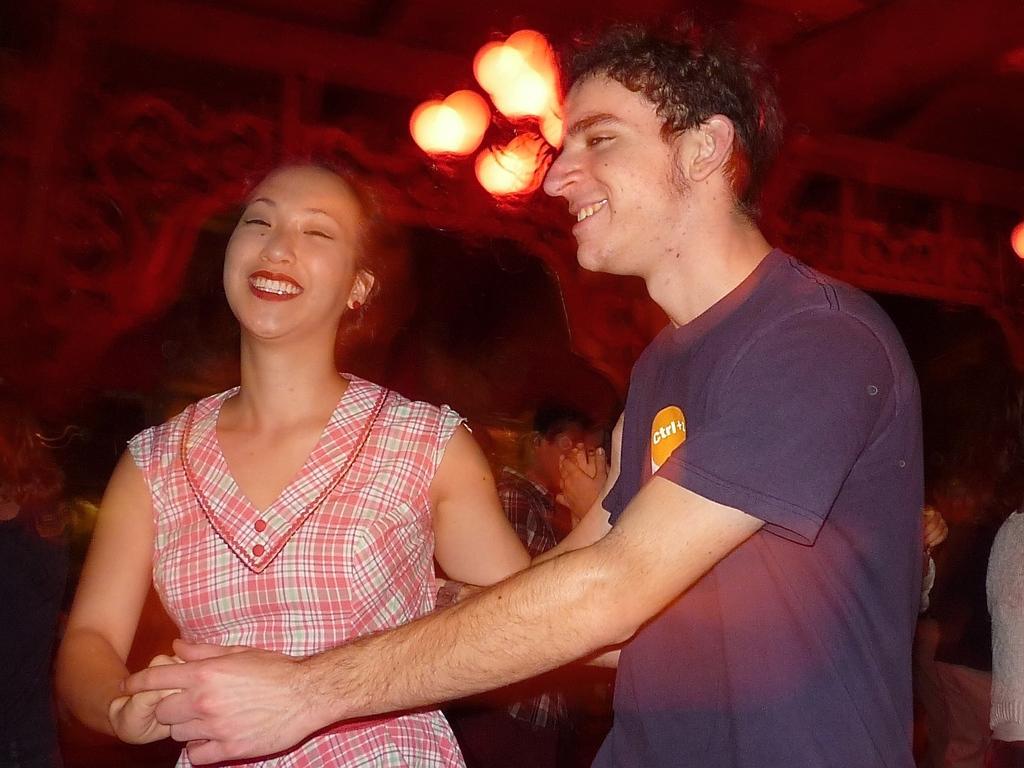Could you give a brief overview of what you see in this image? In this image we can see two persons holding each other, there we can see few persons and lights. 